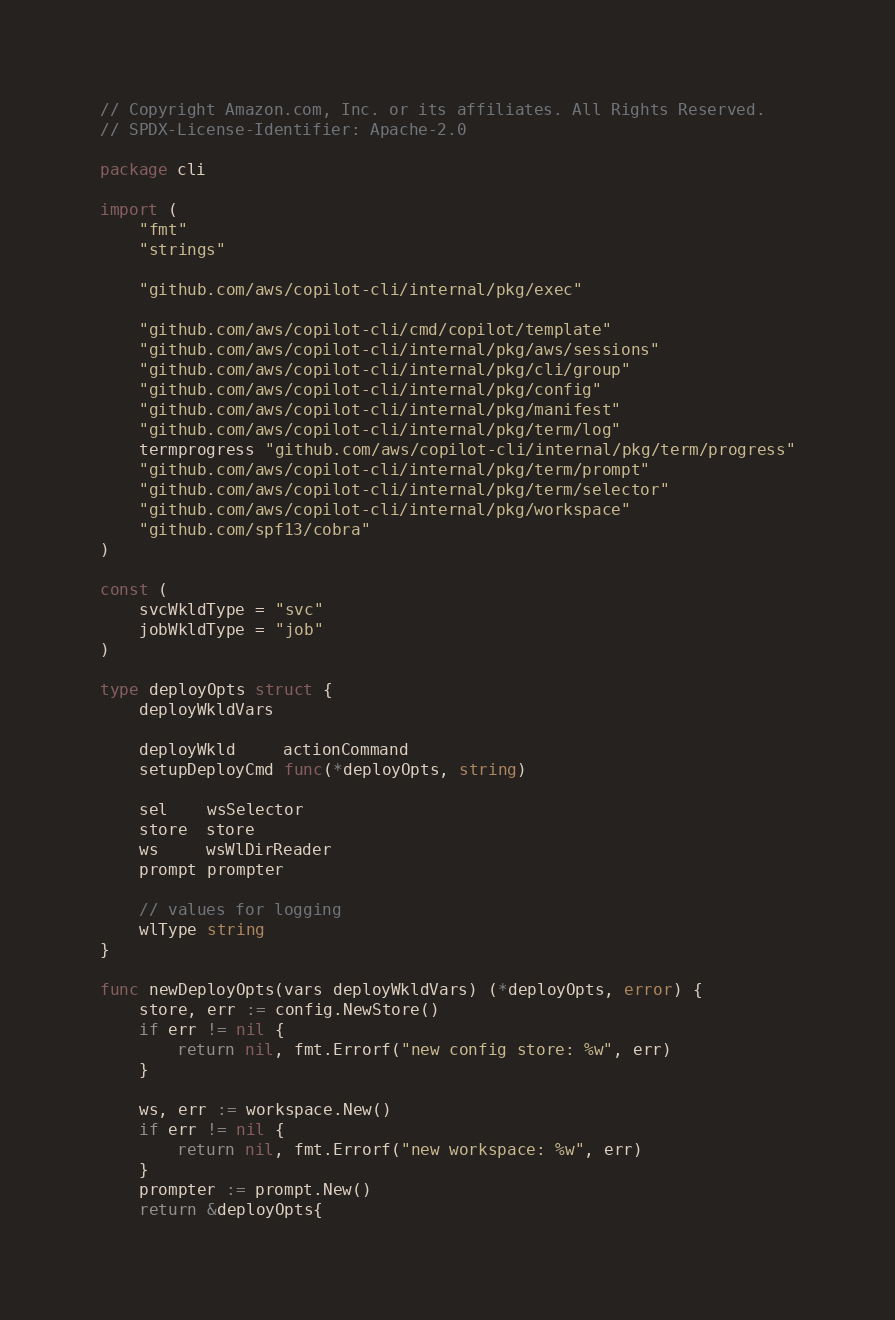Convert code to text. <code><loc_0><loc_0><loc_500><loc_500><_Go_>// Copyright Amazon.com, Inc. or its affiliates. All Rights Reserved.
// SPDX-License-Identifier: Apache-2.0

package cli

import (
	"fmt"
	"strings"

	"github.com/aws/copilot-cli/internal/pkg/exec"

	"github.com/aws/copilot-cli/cmd/copilot/template"
	"github.com/aws/copilot-cli/internal/pkg/aws/sessions"
	"github.com/aws/copilot-cli/internal/pkg/cli/group"
	"github.com/aws/copilot-cli/internal/pkg/config"
	"github.com/aws/copilot-cli/internal/pkg/manifest"
	"github.com/aws/copilot-cli/internal/pkg/term/log"
	termprogress "github.com/aws/copilot-cli/internal/pkg/term/progress"
	"github.com/aws/copilot-cli/internal/pkg/term/prompt"
	"github.com/aws/copilot-cli/internal/pkg/term/selector"
	"github.com/aws/copilot-cli/internal/pkg/workspace"
	"github.com/spf13/cobra"
)

const (
	svcWkldType = "svc"
	jobWkldType = "job"
)

type deployOpts struct {
	deployWkldVars

	deployWkld     actionCommand
	setupDeployCmd func(*deployOpts, string)

	sel    wsSelector
	store  store
	ws     wsWlDirReader
	prompt prompter

	// values for logging
	wlType string
}

func newDeployOpts(vars deployWkldVars) (*deployOpts, error) {
	store, err := config.NewStore()
	if err != nil {
		return nil, fmt.Errorf("new config store: %w", err)
	}

	ws, err := workspace.New()
	if err != nil {
		return nil, fmt.Errorf("new workspace: %w", err)
	}
	prompter := prompt.New()
	return &deployOpts{</code> 